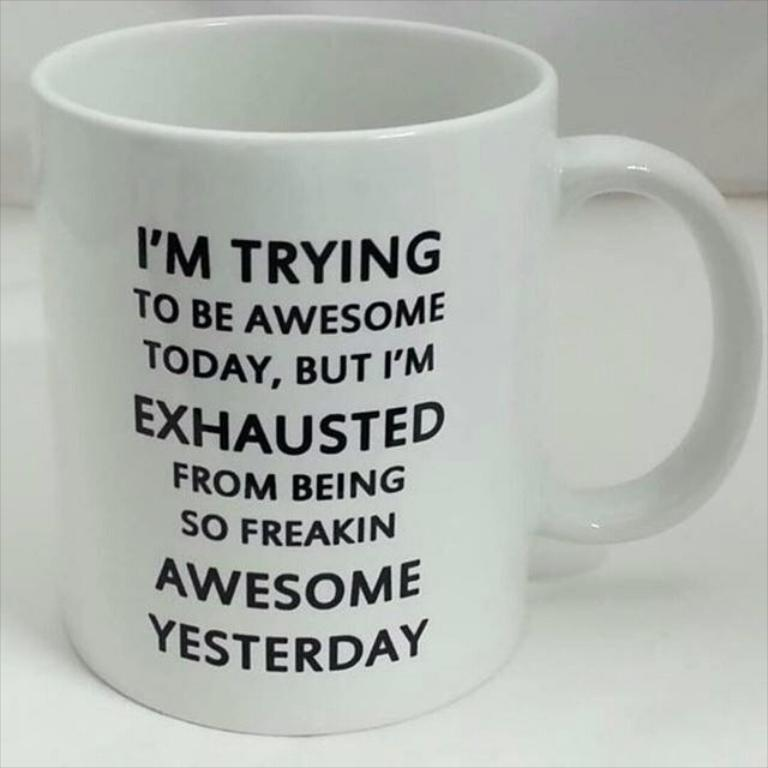<image>
Offer a succinct explanation of the picture presented. The mug features the catchphrase "I'm trying to be awesome today". 